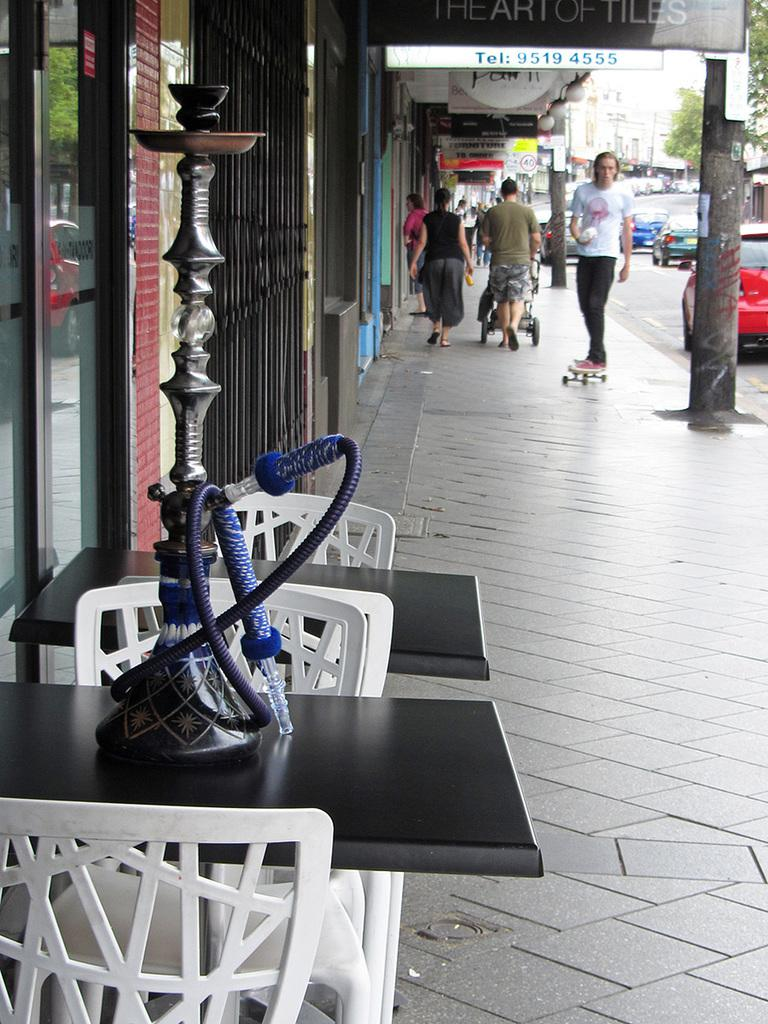What types of objects can be seen in the image? There are vehicles, buildings, trees, boards with text, chairs, and tables in the image. What is present on the table in the image? There is a hookah pot on the table in the image. Can you describe the surroundings in the image? The surroundings include buildings, trees, and possibly other structures. What might be used for sitting or resting in the image? Chairs and tables are present in the image for sitting or resting. How many sisters are shaking hands in the image? There are no sisters present in the image, nor is there any hand-shaking activity. What type of bone can be seen in the image? There is no bone present in the image. 